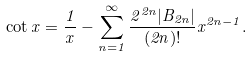<formula> <loc_0><loc_0><loc_500><loc_500>\cot x = \frac { 1 } { x } - \sum _ { n = 1 } ^ { \infty } \frac { 2 ^ { 2 n } | B _ { 2 n } | } { ( 2 n ) ! } x ^ { 2 n - 1 } .</formula> 